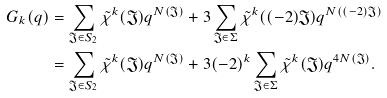Convert formula to latex. <formula><loc_0><loc_0><loc_500><loc_500>G _ { k } ( q ) & = \sum _ { \mathfrak J \in S _ { 2 } } \tilde { \chi } ^ { k } ( \mathfrak J ) q ^ { N ( \mathfrak J ) } + 3 \sum _ { \mathfrak J \in \Sigma } \tilde { \chi } ^ { k } ( ( - 2 ) \mathfrak J ) q ^ { N ( ( - 2 ) \mathfrak J ) } \\ & = \sum _ { \mathfrak J \in S _ { 2 } } \tilde { \chi } ^ { k } ( \mathfrak J ) q ^ { N ( \mathfrak J ) } + 3 ( - 2 ) ^ { k } \sum _ { \mathfrak J \in \Sigma } \tilde { \chi } ^ { k } ( \mathfrak J ) q ^ { 4 N ( \mathfrak J ) } .</formula> 